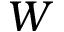Convert formula to latex. <formula><loc_0><loc_0><loc_500><loc_500>W</formula> 